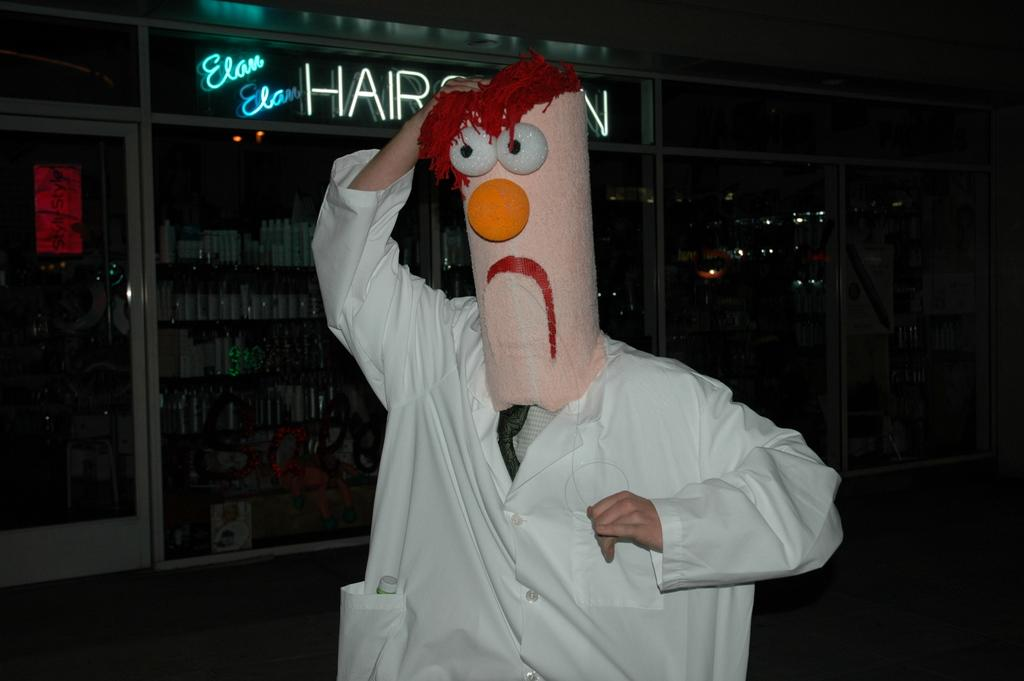Who is present in the image? There is a person in the image. What is the person standing in front of? The person is standing in front of a store. What is the person wearing on their face? The person is wearing a mask that covers their head. What color is the person's shirt? The person is wearing a white shirt. How is the person holding the mask? The person is holding the mask with one hand. How many children are playing with the cushion in the image? There are no children or cushions present in the image. 